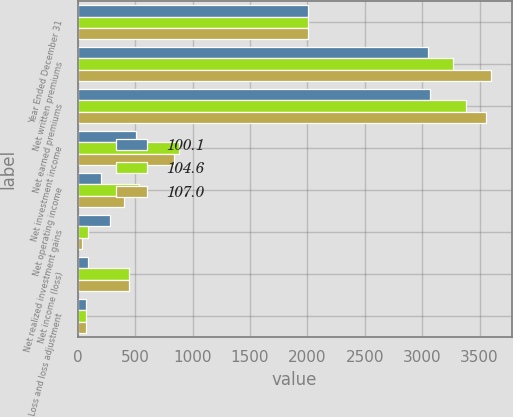<chart> <loc_0><loc_0><loc_500><loc_500><stacked_bar_chart><ecel><fcel>Year Ended December 31<fcel>Net written premiums<fcel>Net earned premiums<fcel>Net investment income<fcel>Net operating income<fcel>Net realized investment gains<fcel>Net income (loss)<fcel>Loss and loss adjustment<nl><fcel>100.1<fcel>2008<fcel>3054<fcel>3065<fcel>506<fcel>200<fcel>285<fcel>85<fcel>75.4<nl><fcel>104.6<fcel>2007<fcel>3267<fcel>3379<fcel>878<fcel>536<fcel>87<fcel>449<fcel>67.4<nl><fcel>107<fcel>2006<fcel>3598<fcel>3557<fcel>840<fcel>405<fcel>41<fcel>446<fcel>72.5<nl></chart> 